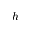<formula> <loc_0><loc_0><loc_500><loc_500>h</formula> 